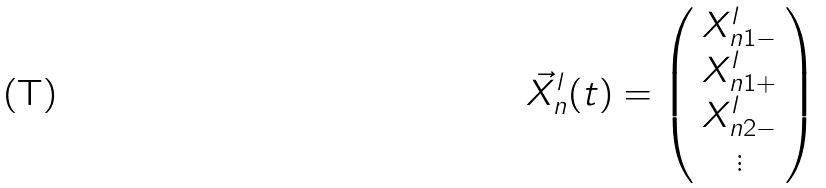<formula> <loc_0><loc_0><loc_500><loc_500>{ \vec { X } } _ { n } ^ { l } ( t ) = \left ( \begin{array} { c } X _ { n 1 - } ^ { l } \\ X _ { n 1 + } ^ { l } \\ X _ { n 2 - } ^ { l } \\ \vdots \end{array} \right )</formula> 